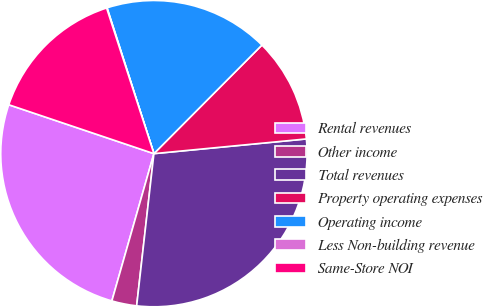Convert chart. <chart><loc_0><loc_0><loc_500><loc_500><pie_chart><fcel>Rental revenues<fcel>Other income<fcel>Total revenues<fcel>Property operating expenses<fcel>Operating income<fcel>Less Non-building revenue<fcel>Same-Store NOI<nl><fcel>25.75%<fcel>2.63%<fcel>28.33%<fcel>11.01%<fcel>17.41%<fcel>0.05%<fcel>14.83%<nl></chart> 